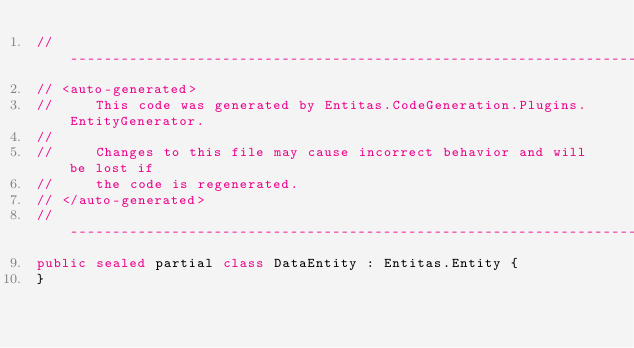Convert code to text. <code><loc_0><loc_0><loc_500><loc_500><_C#_>//------------------------------------------------------------------------------
// <auto-generated>
//     This code was generated by Entitas.CodeGeneration.Plugins.EntityGenerator.
//
//     Changes to this file may cause incorrect behavior and will be lost if
//     the code is regenerated.
// </auto-generated>
//------------------------------------------------------------------------------
public sealed partial class DataEntity : Entitas.Entity {
}
</code> 